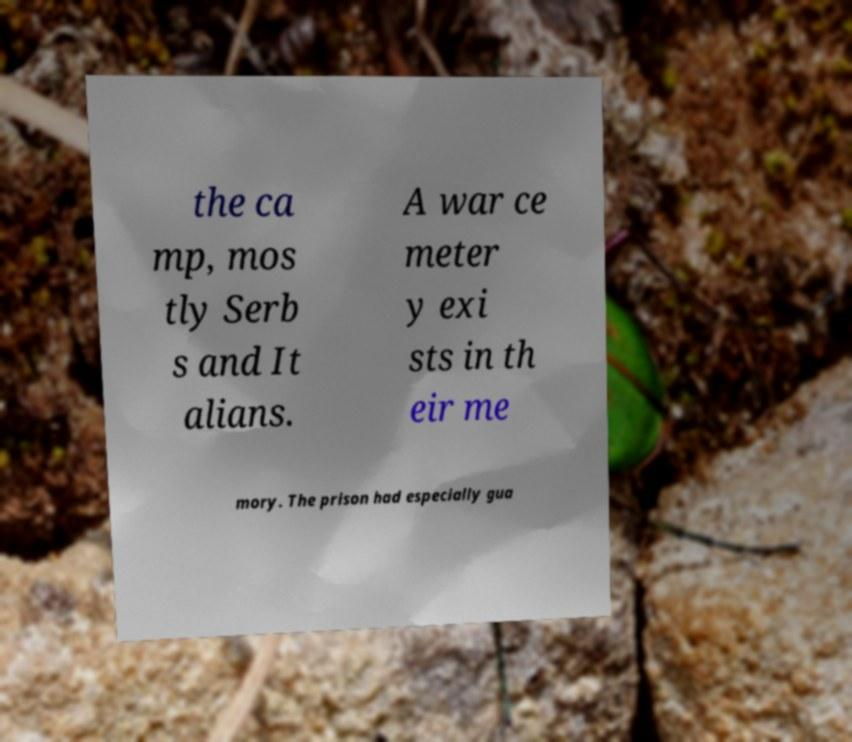Please read and relay the text visible in this image. What does it say? the ca mp, mos tly Serb s and It alians. A war ce meter y exi sts in th eir me mory. The prison had especially gua 